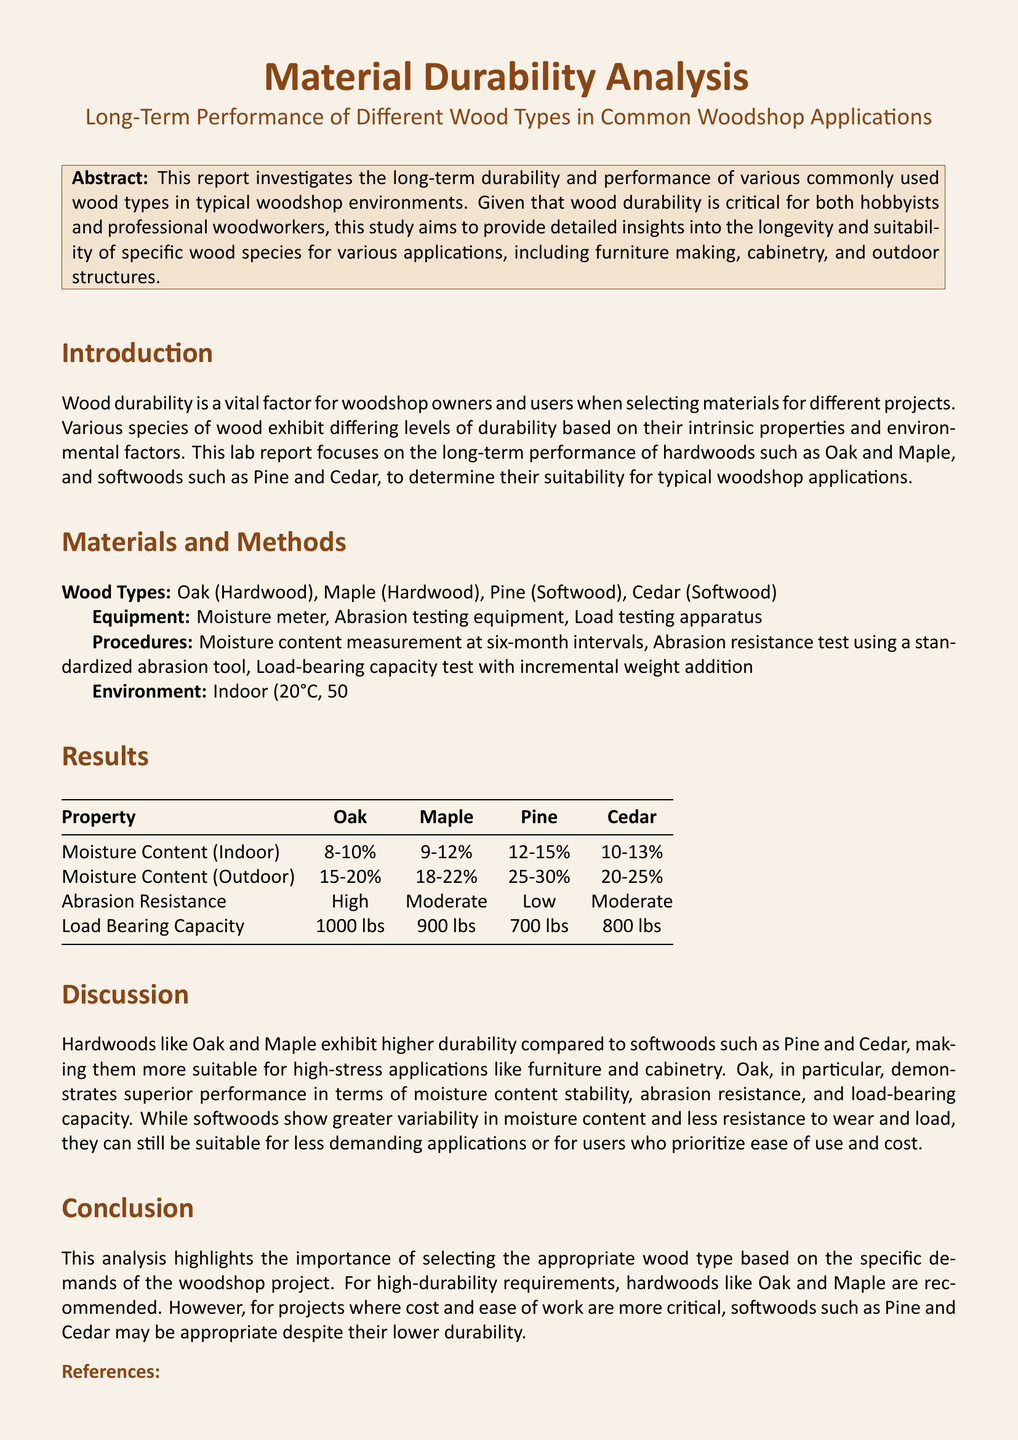What is the purpose of this report? The purpose is to investigate the long-term durability and performance of various commonly used wood types in woodshop environments.
Answer: Investigate durability and performance of wood types How many wood types are analyzed in the report? The report analyzes four wood types: Oak, Maple, Pine, and Cedar.
Answer: Four What is the abrasion resistance of Oak? The abrasion resistance of Oak is classified as high according to the results section.
Answer: High What is the load-bearing capacity of Maple? The load-bearing capacity of Maple is specified as 900 lbs in the document.
Answer: 900 lbs Which wood type has the highest moisture content when exposed outdoors? The wood type with the highest moisture content outdoors is Pine, with a range of 25-30%.
Answer: Pine In which environment was the moisture content of all wood types measured? The moisture content measurements were taken in both indoor and outdoor environments mentioned in the materials and methods section.
Answer: Indoor and outdoor What is the conclusion regarding softwoods? The conclusion states that softwoods like Pine and Cedar may be appropriate for projects where cost and ease are prioritized despite lower durability.
Answer: Cost and ease of use What two hardwoods are highlighted for high-durability requirements? The hardwoods highlighted for high-durability requirements are Oak and Maple.
Answer: Oak and Maple 